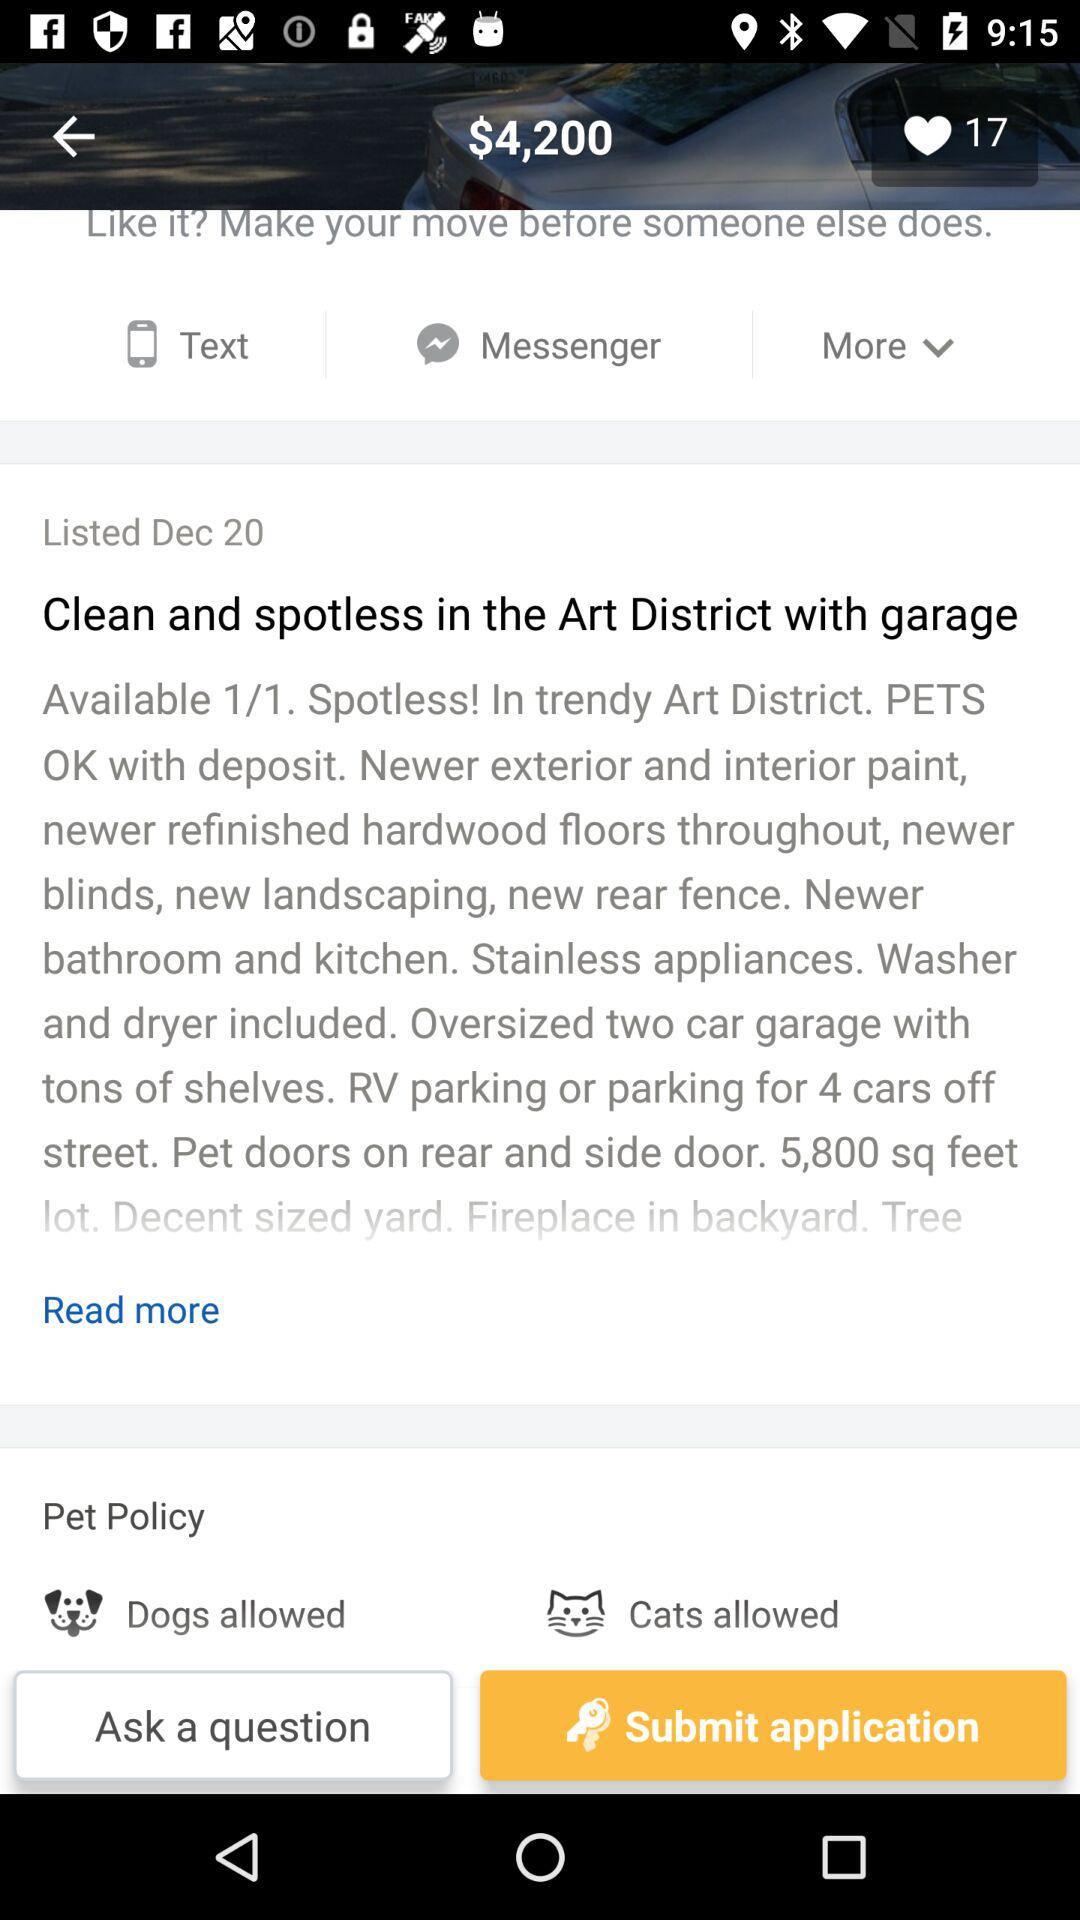Are reptiles allowed?
When the provided information is insufficient, respond with <no answer>. <no answer> 